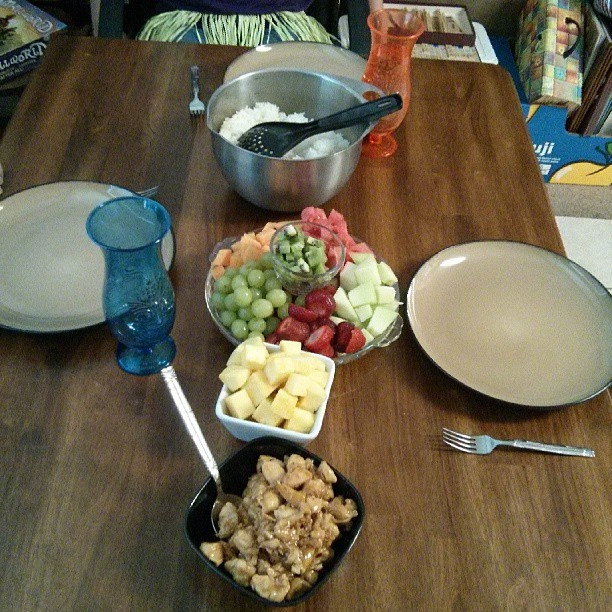Describe the objects in this image and their specific colors. I can see dining table in gray, black, and maroon tones, bowl in gray, olive, maroon, darkgreen, and beige tones, bowl in gray, black, darkgray, and ivory tones, bowl in gray, black, tan, and olive tones, and vase in gray, blue, darkblue, navy, and teal tones in this image. 